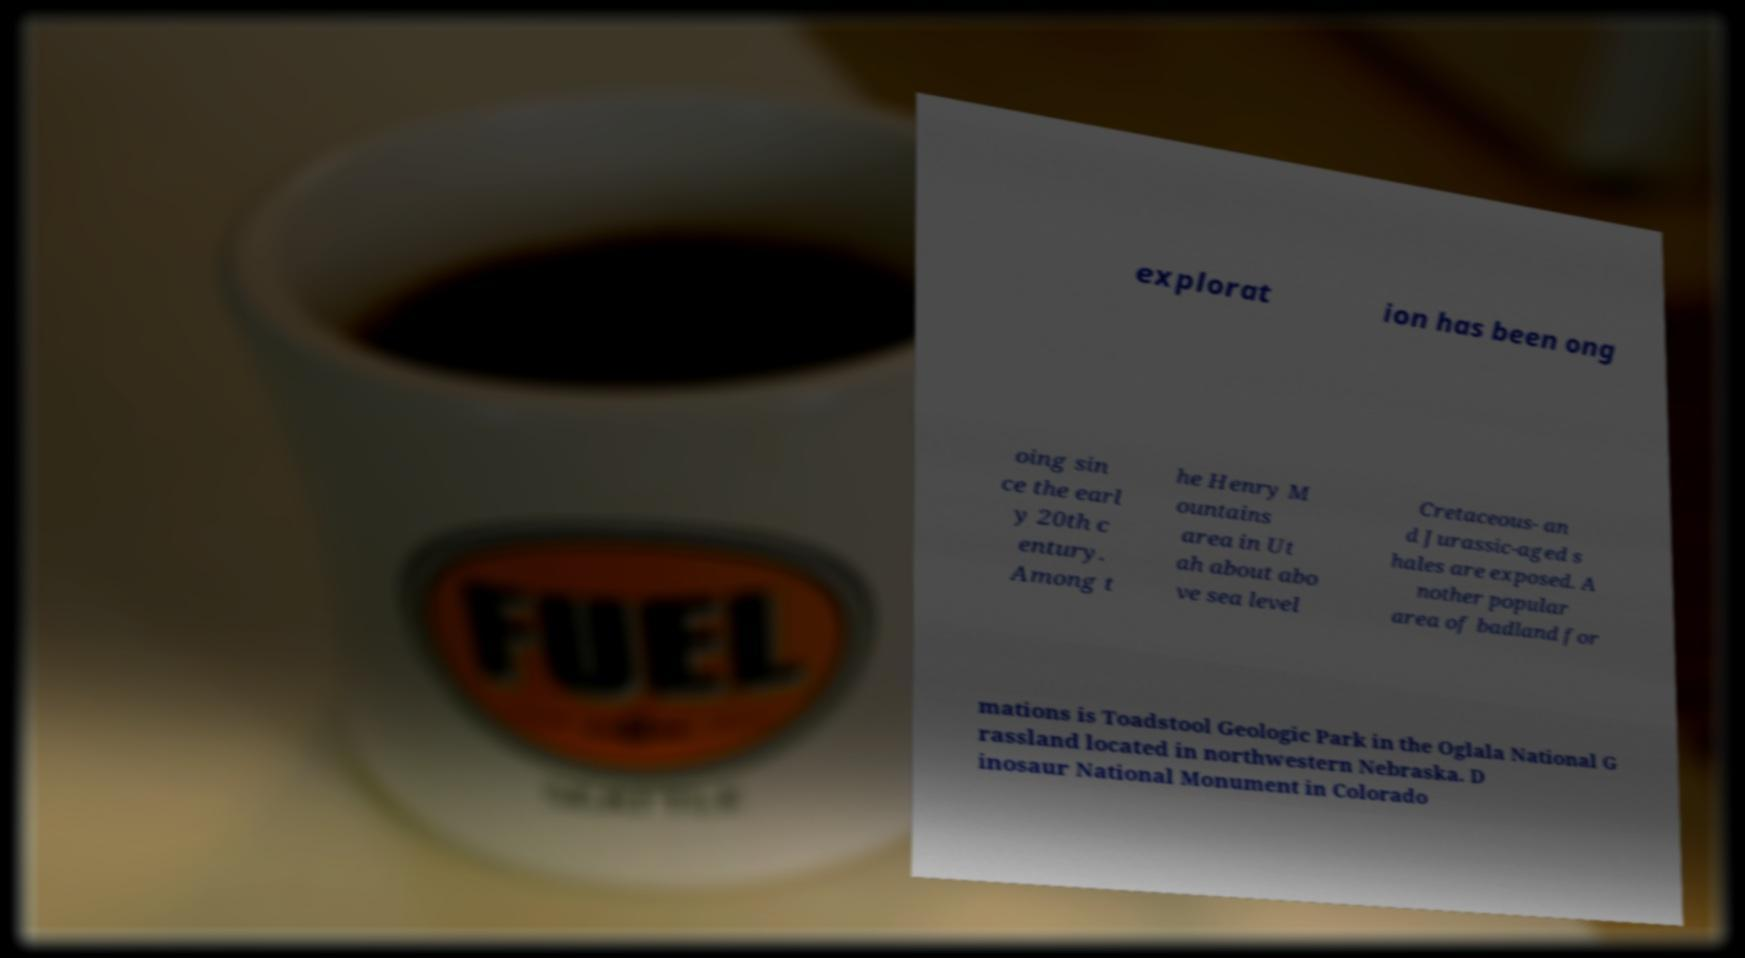Please read and relay the text visible in this image. What does it say? explorat ion has been ong oing sin ce the earl y 20th c entury. Among t he Henry M ountains area in Ut ah about abo ve sea level Cretaceous- an d Jurassic-aged s hales are exposed. A nother popular area of badland for mations is Toadstool Geologic Park in the Oglala National G rassland located in northwestern Nebraska. D inosaur National Monument in Colorado 